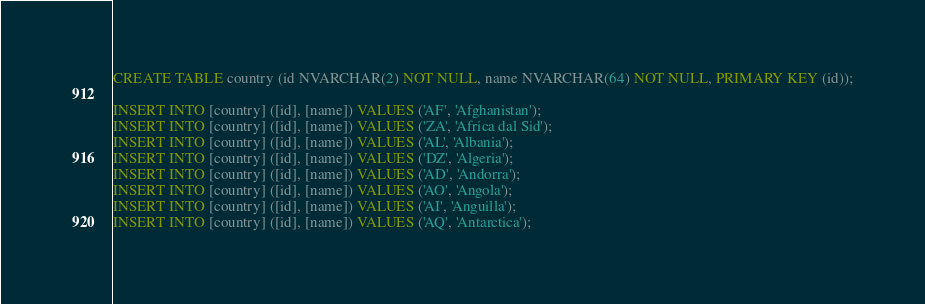<code> <loc_0><loc_0><loc_500><loc_500><_SQL_>CREATE TABLE country (id NVARCHAR(2) NOT NULL, name NVARCHAR(64) NOT NULL, PRIMARY KEY (id));

INSERT INTO [country] ([id], [name]) VALUES ('AF', 'Afghanistan');
INSERT INTO [country] ([id], [name]) VALUES ('ZA', 'Africa dal Sid');
INSERT INTO [country] ([id], [name]) VALUES ('AL', 'Albania');
INSERT INTO [country] ([id], [name]) VALUES ('DZ', 'Algeria');
INSERT INTO [country] ([id], [name]) VALUES ('AD', 'Andorra');
INSERT INTO [country] ([id], [name]) VALUES ('AO', 'Angola');
INSERT INTO [country] ([id], [name]) VALUES ('AI', 'Anguilla');
INSERT INTO [country] ([id], [name]) VALUES ('AQ', 'Antarctica');</code> 